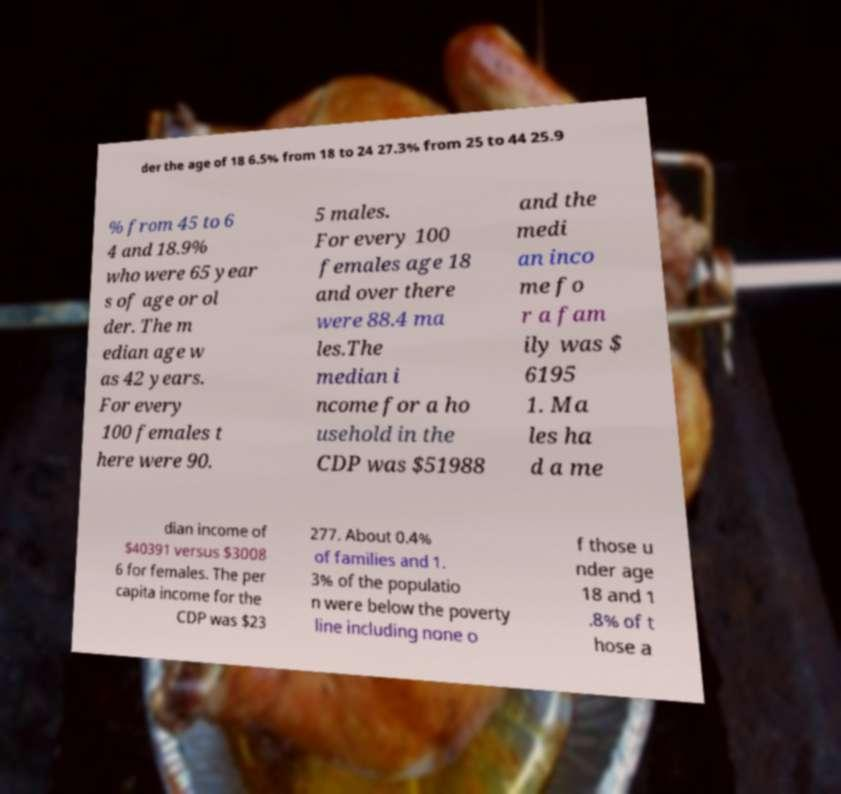Please identify and transcribe the text found in this image. der the age of 18 6.5% from 18 to 24 27.3% from 25 to 44 25.9 % from 45 to 6 4 and 18.9% who were 65 year s of age or ol der. The m edian age w as 42 years. For every 100 females t here were 90. 5 males. For every 100 females age 18 and over there were 88.4 ma les.The median i ncome for a ho usehold in the CDP was $51988 and the medi an inco me fo r a fam ily was $ 6195 1. Ma les ha d a me dian income of $40391 versus $3008 6 for females. The per capita income for the CDP was $23 277. About 0.4% of families and 1. 3% of the populatio n were below the poverty line including none o f those u nder age 18 and 1 .8% of t hose a 